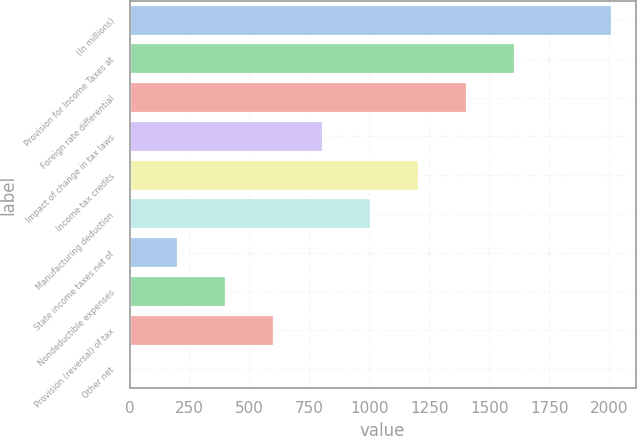Convert chart to OTSL. <chart><loc_0><loc_0><loc_500><loc_500><bar_chart><fcel>(In millions)<fcel>Provision for Income Taxes at<fcel>Foreign rate differential<fcel>Impact of change in tax laws<fcel>Income tax credits<fcel>Manufacturing deduction<fcel>State income taxes net of<fcel>Nondeductible expenses<fcel>Provision (reversal) of tax<fcel>Other net<nl><fcel>2010<fcel>1608.4<fcel>1407.6<fcel>805.2<fcel>1206.8<fcel>1006<fcel>202.8<fcel>403.6<fcel>604.4<fcel>2<nl></chart> 